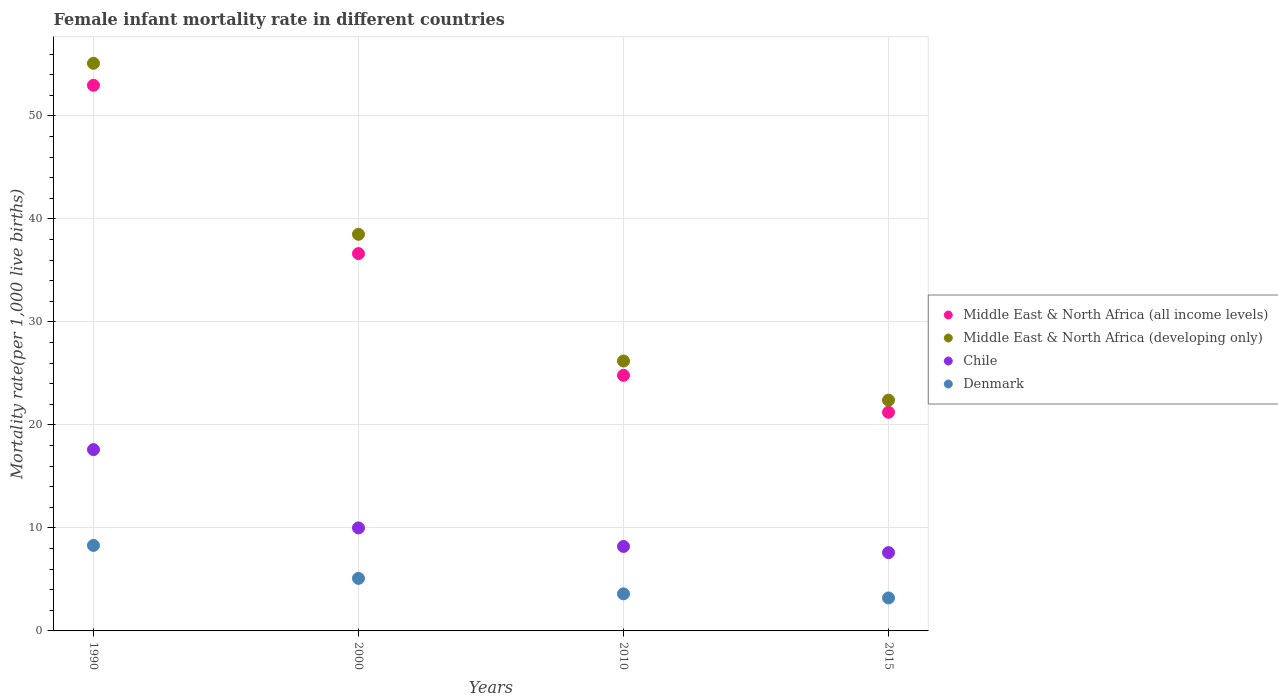How many different coloured dotlines are there?
Offer a terse response. 4. Is the number of dotlines equal to the number of legend labels?
Your answer should be very brief. Yes. What is the female infant mortality rate in Middle East & North Africa (developing only) in 2010?
Your answer should be compact. 26.2. Across all years, what is the maximum female infant mortality rate in Chile?
Make the answer very short. 17.6. Across all years, what is the minimum female infant mortality rate in Middle East & North Africa (all income levels)?
Make the answer very short. 21.23. In which year was the female infant mortality rate in Middle East & North Africa (all income levels) maximum?
Give a very brief answer. 1990. In which year was the female infant mortality rate in Chile minimum?
Provide a short and direct response. 2015. What is the total female infant mortality rate in Chile in the graph?
Offer a terse response. 43.4. What is the difference between the female infant mortality rate in Denmark in 1990 and that in 2015?
Your response must be concise. 5.1. What is the average female infant mortality rate in Middle East & North Africa (all income levels) per year?
Make the answer very short. 33.91. In the year 1990, what is the difference between the female infant mortality rate in Middle East & North Africa (all income levels) and female infant mortality rate in Chile?
Provide a succinct answer. 35.37. In how many years, is the female infant mortality rate in Middle East & North Africa (developing only) greater than 54?
Provide a succinct answer. 1. What is the ratio of the female infant mortality rate in Middle East & North Africa (all income levels) in 2000 to that in 2015?
Your response must be concise. 1.73. What is the difference between the highest and the lowest female infant mortality rate in Chile?
Your answer should be very brief. 10. In how many years, is the female infant mortality rate in Chile greater than the average female infant mortality rate in Chile taken over all years?
Provide a succinct answer. 1. Is the sum of the female infant mortality rate in Middle East & North Africa (all income levels) in 2010 and 2015 greater than the maximum female infant mortality rate in Middle East & North Africa (developing only) across all years?
Keep it short and to the point. No. How many dotlines are there?
Keep it short and to the point. 4. Are the values on the major ticks of Y-axis written in scientific E-notation?
Provide a succinct answer. No. Where does the legend appear in the graph?
Provide a succinct answer. Center right. How many legend labels are there?
Offer a very short reply. 4. What is the title of the graph?
Give a very brief answer. Female infant mortality rate in different countries. Does "Seychelles" appear as one of the legend labels in the graph?
Provide a succinct answer. No. What is the label or title of the Y-axis?
Your answer should be compact. Mortality rate(per 1,0 live births). What is the Mortality rate(per 1,000 live births) in Middle East & North Africa (all income levels) in 1990?
Your answer should be compact. 52.97. What is the Mortality rate(per 1,000 live births) in Middle East & North Africa (developing only) in 1990?
Give a very brief answer. 55.1. What is the Mortality rate(per 1,000 live births) of Chile in 1990?
Make the answer very short. 17.6. What is the Mortality rate(per 1,000 live births) of Middle East & North Africa (all income levels) in 2000?
Provide a short and direct response. 36.63. What is the Mortality rate(per 1,000 live births) of Middle East & North Africa (developing only) in 2000?
Your answer should be compact. 38.5. What is the Mortality rate(per 1,000 live births) of Chile in 2000?
Your response must be concise. 10. What is the Mortality rate(per 1,000 live births) of Middle East & North Africa (all income levels) in 2010?
Keep it short and to the point. 24.81. What is the Mortality rate(per 1,000 live births) of Middle East & North Africa (developing only) in 2010?
Offer a very short reply. 26.2. What is the Mortality rate(per 1,000 live births) in Chile in 2010?
Offer a terse response. 8.2. What is the Mortality rate(per 1,000 live births) in Middle East & North Africa (all income levels) in 2015?
Offer a very short reply. 21.23. What is the Mortality rate(per 1,000 live births) of Middle East & North Africa (developing only) in 2015?
Offer a very short reply. 22.4. What is the Mortality rate(per 1,000 live births) of Chile in 2015?
Make the answer very short. 7.6. What is the Mortality rate(per 1,000 live births) of Denmark in 2015?
Give a very brief answer. 3.2. Across all years, what is the maximum Mortality rate(per 1,000 live births) of Middle East & North Africa (all income levels)?
Keep it short and to the point. 52.97. Across all years, what is the maximum Mortality rate(per 1,000 live births) of Middle East & North Africa (developing only)?
Give a very brief answer. 55.1. Across all years, what is the maximum Mortality rate(per 1,000 live births) in Chile?
Your answer should be very brief. 17.6. Across all years, what is the minimum Mortality rate(per 1,000 live births) of Middle East & North Africa (all income levels)?
Your response must be concise. 21.23. Across all years, what is the minimum Mortality rate(per 1,000 live births) in Middle East & North Africa (developing only)?
Your answer should be compact. 22.4. Across all years, what is the minimum Mortality rate(per 1,000 live births) in Chile?
Offer a terse response. 7.6. Across all years, what is the minimum Mortality rate(per 1,000 live births) of Denmark?
Give a very brief answer. 3.2. What is the total Mortality rate(per 1,000 live births) of Middle East & North Africa (all income levels) in the graph?
Provide a succinct answer. 135.63. What is the total Mortality rate(per 1,000 live births) of Middle East & North Africa (developing only) in the graph?
Provide a short and direct response. 142.2. What is the total Mortality rate(per 1,000 live births) of Chile in the graph?
Give a very brief answer. 43.4. What is the total Mortality rate(per 1,000 live births) in Denmark in the graph?
Ensure brevity in your answer.  20.2. What is the difference between the Mortality rate(per 1,000 live births) of Middle East & North Africa (all income levels) in 1990 and that in 2000?
Offer a very short reply. 16.34. What is the difference between the Mortality rate(per 1,000 live births) of Middle East & North Africa (developing only) in 1990 and that in 2000?
Ensure brevity in your answer.  16.6. What is the difference between the Mortality rate(per 1,000 live births) in Middle East & North Africa (all income levels) in 1990 and that in 2010?
Provide a short and direct response. 28.15. What is the difference between the Mortality rate(per 1,000 live births) in Middle East & North Africa (developing only) in 1990 and that in 2010?
Keep it short and to the point. 28.9. What is the difference between the Mortality rate(per 1,000 live births) of Chile in 1990 and that in 2010?
Your answer should be very brief. 9.4. What is the difference between the Mortality rate(per 1,000 live births) in Middle East & North Africa (all income levels) in 1990 and that in 2015?
Give a very brief answer. 31.74. What is the difference between the Mortality rate(per 1,000 live births) in Middle East & North Africa (developing only) in 1990 and that in 2015?
Provide a succinct answer. 32.7. What is the difference between the Mortality rate(per 1,000 live births) of Chile in 1990 and that in 2015?
Offer a very short reply. 10. What is the difference between the Mortality rate(per 1,000 live births) in Middle East & North Africa (all income levels) in 2000 and that in 2010?
Provide a short and direct response. 11.81. What is the difference between the Mortality rate(per 1,000 live births) of Middle East & North Africa (all income levels) in 2000 and that in 2015?
Make the answer very short. 15.4. What is the difference between the Mortality rate(per 1,000 live births) of Denmark in 2000 and that in 2015?
Ensure brevity in your answer.  1.9. What is the difference between the Mortality rate(per 1,000 live births) of Middle East & North Africa (all income levels) in 2010 and that in 2015?
Make the answer very short. 3.59. What is the difference between the Mortality rate(per 1,000 live births) of Denmark in 2010 and that in 2015?
Your response must be concise. 0.4. What is the difference between the Mortality rate(per 1,000 live births) in Middle East & North Africa (all income levels) in 1990 and the Mortality rate(per 1,000 live births) in Middle East & North Africa (developing only) in 2000?
Keep it short and to the point. 14.47. What is the difference between the Mortality rate(per 1,000 live births) of Middle East & North Africa (all income levels) in 1990 and the Mortality rate(per 1,000 live births) of Chile in 2000?
Offer a very short reply. 42.97. What is the difference between the Mortality rate(per 1,000 live births) of Middle East & North Africa (all income levels) in 1990 and the Mortality rate(per 1,000 live births) of Denmark in 2000?
Keep it short and to the point. 47.87. What is the difference between the Mortality rate(per 1,000 live births) of Middle East & North Africa (developing only) in 1990 and the Mortality rate(per 1,000 live births) of Chile in 2000?
Keep it short and to the point. 45.1. What is the difference between the Mortality rate(per 1,000 live births) in Chile in 1990 and the Mortality rate(per 1,000 live births) in Denmark in 2000?
Your answer should be very brief. 12.5. What is the difference between the Mortality rate(per 1,000 live births) in Middle East & North Africa (all income levels) in 1990 and the Mortality rate(per 1,000 live births) in Middle East & North Africa (developing only) in 2010?
Give a very brief answer. 26.77. What is the difference between the Mortality rate(per 1,000 live births) of Middle East & North Africa (all income levels) in 1990 and the Mortality rate(per 1,000 live births) of Chile in 2010?
Ensure brevity in your answer.  44.77. What is the difference between the Mortality rate(per 1,000 live births) in Middle East & North Africa (all income levels) in 1990 and the Mortality rate(per 1,000 live births) in Denmark in 2010?
Ensure brevity in your answer.  49.37. What is the difference between the Mortality rate(per 1,000 live births) of Middle East & North Africa (developing only) in 1990 and the Mortality rate(per 1,000 live births) of Chile in 2010?
Your answer should be compact. 46.9. What is the difference between the Mortality rate(per 1,000 live births) in Middle East & North Africa (developing only) in 1990 and the Mortality rate(per 1,000 live births) in Denmark in 2010?
Offer a very short reply. 51.5. What is the difference between the Mortality rate(per 1,000 live births) in Middle East & North Africa (all income levels) in 1990 and the Mortality rate(per 1,000 live births) in Middle East & North Africa (developing only) in 2015?
Give a very brief answer. 30.57. What is the difference between the Mortality rate(per 1,000 live births) of Middle East & North Africa (all income levels) in 1990 and the Mortality rate(per 1,000 live births) of Chile in 2015?
Give a very brief answer. 45.37. What is the difference between the Mortality rate(per 1,000 live births) in Middle East & North Africa (all income levels) in 1990 and the Mortality rate(per 1,000 live births) in Denmark in 2015?
Keep it short and to the point. 49.77. What is the difference between the Mortality rate(per 1,000 live births) in Middle East & North Africa (developing only) in 1990 and the Mortality rate(per 1,000 live births) in Chile in 2015?
Keep it short and to the point. 47.5. What is the difference between the Mortality rate(per 1,000 live births) in Middle East & North Africa (developing only) in 1990 and the Mortality rate(per 1,000 live births) in Denmark in 2015?
Your answer should be very brief. 51.9. What is the difference between the Mortality rate(per 1,000 live births) in Middle East & North Africa (all income levels) in 2000 and the Mortality rate(per 1,000 live births) in Middle East & North Africa (developing only) in 2010?
Offer a very short reply. 10.43. What is the difference between the Mortality rate(per 1,000 live births) in Middle East & North Africa (all income levels) in 2000 and the Mortality rate(per 1,000 live births) in Chile in 2010?
Offer a terse response. 28.43. What is the difference between the Mortality rate(per 1,000 live births) in Middle East & North Africa (all income levels) in 2000 and the Mortality rate(per 1,000 live births) in Denmark in 2010?
Make the answer very short. 33.03. What is the difference between the Mortality rate(per 1,000 live births) in Middle East & North Africa (developing only) in 2000 and the Mortality rate(per 1,000 live births) in Chile in 2010?
Keep it short and to the point. 30.3. What is the difference between the Mortality rate(per 1,000 live births) of Middle East & North Africa (developing only) in 2000 and the Mortality rate(per 1,000 live births) of Denmark in 2010?
Offer a terse response. 34.9. What is the difference between the Mortality rate(per 1,000 live births) of Chile in 2000 and the Mortality rate(per 1,000 live births) of Denmark in 2010?
Provide a succinct answer. 6.4. What is the difference between the Mortality rate(per 1,000 live births) in Middle East & North Africa (all income levels) in 2000 and the Mortality rate(per 1,000 live births) in Middle East & North Africa (developing only) in 2015?
Your response must be concise. 14.23. What is the difference between the Mortality rate(per 1,000 live births) in Middle East & North Africa (all income levels) in 2000 and the Mortality rate(per 1,000 live births) in Chile in 2015?
Give a very brief answer. 29.03. What is the difference between the Mortality rate(per 1,000 live births) in Middle East & North Africa (all income levels) in 2000 and the Mortality rate(per 1,000 live births) in Denmark in 2015?
Your answer should be very brief. 33.43. What is the difference between the Mortality rate(per 1,000 live births) in Middle East & North Africa (developing only) in 2000 and the Mortality rate(per 1,000 live births) in Chile in 2015?
Your response must be concise. 30.9. What is the difference between the Mortality rate(per 1,000 live births) of Middle East & North Africa (developing only) in 2000 and the Mortality rate(per 1,000 live births) of Denmark in 2015?
Your response must be concise. 35.3. What is the difference between the Mortality rate(per 1,000 live births) of Middle East & North Africa (all income levels) in 2010 and the Mortality rate(per 1,000 live births) of Middle East & North Africa (developing only) in 2015?
Your answer should be very brief. 2.41. What is the difference between the Mortality rate(per 1,000 live births) in Middle East & North Africa (all income levels) in 2010 and the Mortality rate(per 1,000 live births) in Chile in 2015?
Keep it short and to the point. 17.21. What is the difference between the Mortality rate(per 1,000 live births) in Middle East & North Africa (all income levels) in 2010 and the Mortality rate(per 1,000 live births) in Denmark in 2015?
Your answer should be compact. 21.61. What is the difference between the Mortality rate(per 1,000 live births) of Chile in 2010 and the Mortality rate(per 1,000 live births) of Denmark in 2015?
Give a very brief answer. 5. What is the average Mortality rate(per 1,000 live births) in Middle East & North Africa (all income levels) per year?
Make the answer very short. 33.91. What is the average Mortality rate(per 1,000 live births) in Middle East & North Africa (developing only) per year?
Offer a very short reply. 35.55. What is the average Mortality rate(per 1,000 live births) in Chile per year?
Make the answer very short. 10.85. What is the average Mortality rate(per 1,000 live births) of Denmark per year?
Ensure brevity in your answer.  5.05. In the year 1990, what is the difference between the Mortality rate(per 1,000 live births) in Middle East & North Africa (all income levels) and Mortality rate(per 1,000 live births) in Middle East & North Africa (developing only)?
Ensure brevity in your answer.  -2.13. In the year 1990, what is the difference between the Mortality rate(per 1,000 live births) in Middle East & North Africa (all income levels) and Mortality rate(per 1,000 live births) in Chile?
Give a very brief answer. 35.37. In the year 1990, what is the difference between the Mortality rate(per 1,000 live births) in Middle East & North Africa (all income levels) and Mortality rate(per 1,000 live births) in Denmark?
Ensure brevity in your answer.  44.67. In the year 1990, what is the difference between the Mortality rate(per 1,000 live births) in Middle East & North Africa (developing only) and Mortality rate(per 1,000 live births) in Chile?
Give a very brief answer. 37.5. In the year 1990, what is the difference between the Mortality rate(per 1,000 live births) in Middle East & North Africa (developing only) and Mortality rate(per 1,000 live births) in Denmark?
Your answer should be very brief. 46.8. In the year 2000, what is the difference between the Mortality rate(per 1,000 live births) in Middle East & North Africa (all income levels) and Mortality rate(per 1,000 live births) in Middle East & North Africa (developing only)?
Give a very brief answer. -1.87. In the year 2000, what is the difference between the Mortality rate(per 1,000 live births) of Middle East & North Africa (all income levels) and Mortality rate(per 1,000 live births) of Chile?
Keep it short and to the point. 26.63. In the year 2000, what is the difference between the Mortality rate(per 1,000 live births) in Middle East & North Africa (all income levels) and Mortality rate(per 1,000 live births) in Denmark?
Ensure brevity in your answer.  31.53. In the year 2000, what is the difference between the Mortality rate(per 1,000 live births) in Middle East & North Africa (developing only) and Mortality rate(per 1,000 live births) in Chile?
Provide a succinct answer. 28.5. In the year 2000, what is the difference between the Mortality rate(per 1,000 live births) of Middle East & North Africa (developing only) and Mortality rate(per 1,000 live births) of Denmark?
Ensure brevity in your answer.  33.4. In the year 2010, what is the difference between the Mortality rate(per 1,000 live births) in Middle East & North Africa (all income levels) and Mortality rate(per 1,000 live births) in Middle East & North Africa (developing only)?
Provide a succinct answer. -1.39. In the year 2010, what is the difference between the Mortality rate(per 1,000 live births) of Middle East & North Africa (all income levels) and Mortality rate(per 1,000 live births) of Chile?
Ensure brevity in your answer.  16.61. In the year 2010, what is the difference between the Mortality rate(per 1,000 live births) of Middle East & North Africa (all income levels) and Mortality rate(per 1,000 live births) of Denmark?
Give a very brief answer. 21.21. In the year 2010, what is the difference between the Mortality rate(per 1,000 live births) of Middle East & North Africa (developing only) and Mortality rate(per 1,000 live births) of Chile?
Your answer should be very brief. 18. In the year 2010, what is the difference between the Mortality rate(per 1,000 live births) in Middle East & North Africa (developing only) and Mortality rate(per 1,000 live births) in Denmark?
Offer a terse response. 22.6. In the year 2010, what is the difference between the Mortality rate(per 1,000 live births) of Chile and Mortality rate(per 1,000 live births) of Denmark?
Offer a very short reply. 4.6. In the year 2015, what is the difference between the Mortality rate(per 1,000 live births) in Middle East & North Africa (all income levels) and Mortality rate(per 1,000 live births) in Middle East & North Africa (developing only)?
Your response must be concise. -1.17. In the year 2015, what is the difference between the Mortality rate(per 1,000 live births) in Middle East & North Africa (all income levels) and Mortality rate(per 1,000 live births) in Chile?
Your answer should be compact. 13.63. In the year 2015, what is the difference between the Mortality rate(per 1,000 live births) of Middle East & North Africa (all income levels) and Mortality rate(per 1,000 live births) of Denmark?
Provide a succinct answer. 18.03. In the year 2015, what is the difference between the Mortality rate(per 1,000 live births) of Middle East & North Africa (developing only) and Mortality rate(per 1,000 live births) of Chile?
Give a very brief answer. 14.8. What is the ratio of the Mortality rate(per 1,000 live births) of Middle East & North Africa (all income levels) in 1990 to that in 2000?
Provide a succinct answer. 1.45. What is the ratio of the Mortality rate(per 1,000 live births) in Middle East & North Africa (developing only) in 1990 to that in 2000?
Provide a short and direct response. 1.43. What is the ratio of the Mortality rate(per 1,000 live births) in Chile in 1990 to that in 2000?
Offer a very short reply. 1.76. What is the ratio of the Mortality rate(per 1,000 live births) in Denmark in 1990 to that in 2000?
Provide a short and direct response. 1.63. What is the ratio of the Mortality rate(per 1,000 live births) of Middle East & North Africa (all income levels) in 1990 to that in 2010?
Give a very brief answer. 2.13. What is the ratio of the Mortality rate(per 1,000 live births) in Middle East & North Africa (developing only) in 1990 to that in 2010?
Provide a short and direct response. 2.1. What is the ratio of the Mortality rate(per 1,000 live births) in Chile in 1990 to that in 2010?
Your answer should be compact. 2.15. What is the ratio of the Mortality rate(per 1,000 live births) in Denmark in 1990 to that in 2010?
Your answer should be very brief. 2.31. What is the ratio of the Mortality rate(per 1,000 live births) of Middle East & North Africa (all income levels) in 1990 to that in 2015?
Provide a short and direct response. 2.5. What is the ratio of the Mortality rate(per 1,000 live births) in Middle East & North Africa (developing only) in 1990 to that in 2015?
Keep it short and to the point. 2.46. What is the ratio of the Mortality rate(per 1,000 live births) in Chile in 1990 to that in 2015?
Offer a very short reply. 2.32. What is the ratio of the Mortality rate(per 1,000 live births) of Denmark in 1990 to that in 2015?
Your response must be concise. 2.59. What is the ratio of the Mortality rate(per 1,000 live births) of Middle East & North Africa (all income levels) in 2000 to that in 2010?
Provide a succinct answer. 1.48. What is the ratio of the Mortality rate(per 1,000 live births) in Middle East & North Africa (developing only) in 2000 to that in 2010?
Keep it short and to the point. 1.47. What is the ratio of the Mortality rate(per 1,000 live births) of Chile in 2000 to that in 2010?
Keep it short and to the point. 1.22. What is the ratio of the Mortality rate(per 1,000 live births) of Denmark in 2000 to that in 2010?
Your answer should be compact. 1.42. What is the ratio of the Mortality rate(per 1,000 live births) in Middle East & North Africa (all income levels) in 2000 to that in 2015?
Offer a terse response. 1.73. What is the ratio of the Mortality rate(per 1,000 live births) in Middle East & North Africa (developing only) in 2000 to that in 2015?
Ensure brevity in your answer.  1.72. What is the ratio of the Mortality rate(per 1,000 live births) in Chile in 2000 to that in 2015?
Your answer should be very brief. 1.32. What is the ratio of the Mortality rate(per 1,000 live births) in Denmark in 2000 to that in 2015?
Offer a terse response. 1.59. What is the ratio of the Mortality rate(per 1,000 live births) of Middle East & North Africa (all income levels) in 2010 to that in 2015?
Keep it short and to the point. 1.17. What is the ratio of the Mortality rate(per 1,000 live births) of Middle East & North Africa (developing only) in 2010 to that in 2015?
Keep it short and to the point. 1.17. What is the ratio of the Mortality rate(per 1,000 live births) in Chile in 2010 to that in 2015?
Your response must be concise. 1.08. What is the difference between the highest and the second highest Mortality rate(per 1,000 live births) in Middle East & North Africa (all income levels)?
Provide a short and direct response. 16.34. What is the difference between the highest and the second highest Mortality rate(per 1,000 live births) of Middle East & North Africa (developing only)?
Your response must be concise. 16.6. What is the difference between the highest and the second highest Mortality rate(per 1,000 live births) of Chile?
Provide a short and direct response. 7.6. What is the difference between the highest and the lowest Mortality rate(per 1,000 live births) of Middle East & North Africa (all income levels)?
Give a very brief answer. 31.74. What is the difference between the highest and the lowest Mortality rate(per 1,000 live births) in Middle East & North Africa (developing only)?
Your answer should be compact. 32.7. 